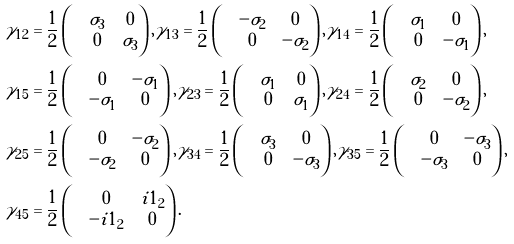<formula> <loc_0><loc_0><loc_500><loc_500>& \gamma _ { 1 2 } = \frac { 1 } { 2 } \begin{pmatrix} & \sigma _ { 3 } & 0 \\ & 0 & \sigma _ { 3 } \end{pmatrix} , \gamma _ { 1 3 } = \frac { 1 } { 2 } \begin{pmatrix} & - \sigma _ { 2 } & 0 \\ & 0 & - \sigma _ { 2 } \end{pmatrix} , \gamma _ { 1 4 } = \frac { 1 } { 2 } \begin{pmatrix} & \sigma _ { 1 } & 0 \\ & 0 & - \sigma _ { 1 } \end{pmatrix} , \\ & \gamma _ { 1 5 } = \frac { 1 } { 2 } \begin{pmatrix} & 0 & - \sigma _ { 1 } \\ & - \sigma _ { 1 } & 0 \end{pmatrix} , \gamma _ { 2 3 } = \frac { 1 } { 2 } \begin{pmatrix} & \sigma _ { 1 } & 0 \\ & 0 & \sigma _ { 1 } \end{pmatrix} , \gamma _ { 2 4 } = \frac { 1 } { 2 } \begin{pmatrix} & \sigma _ { 2 } & 0 \\ & 0 & - \sigma _ { 2 } \end{pmatrix} , \\ & \gamma _ { 2 5 } = \frac { 1 } { 2 } \begin{pmatrix} & 0 & - \sigma _ { 2 } \\ & - \sigma _ { 2 } & 0 \end{pmatrix} , \gamma _ { 3 4 } = \frac { 1 } { 2 } \begin{pmatrix} & \sigma _ { 3 } & 0 \\ & 0 & - \sigma _ { 3 } \end{pmatrix} , \gamma _ { 3 5 } = \frac { 1 } { 2 } \begin{pmatrix} & 0 & - \sigma _ { 3 } \\ & - \sigma _ { 3 } & 0 \end{pmatrix} , \\ & \gamma _ { 4 5 } = \frac { 1 } { 2 } \begin{pmatrix} & 0 & i 1 _ { 2 } \\ & - i 1 _ { 2 } & 0 \end{pmatrix} .</formula> 